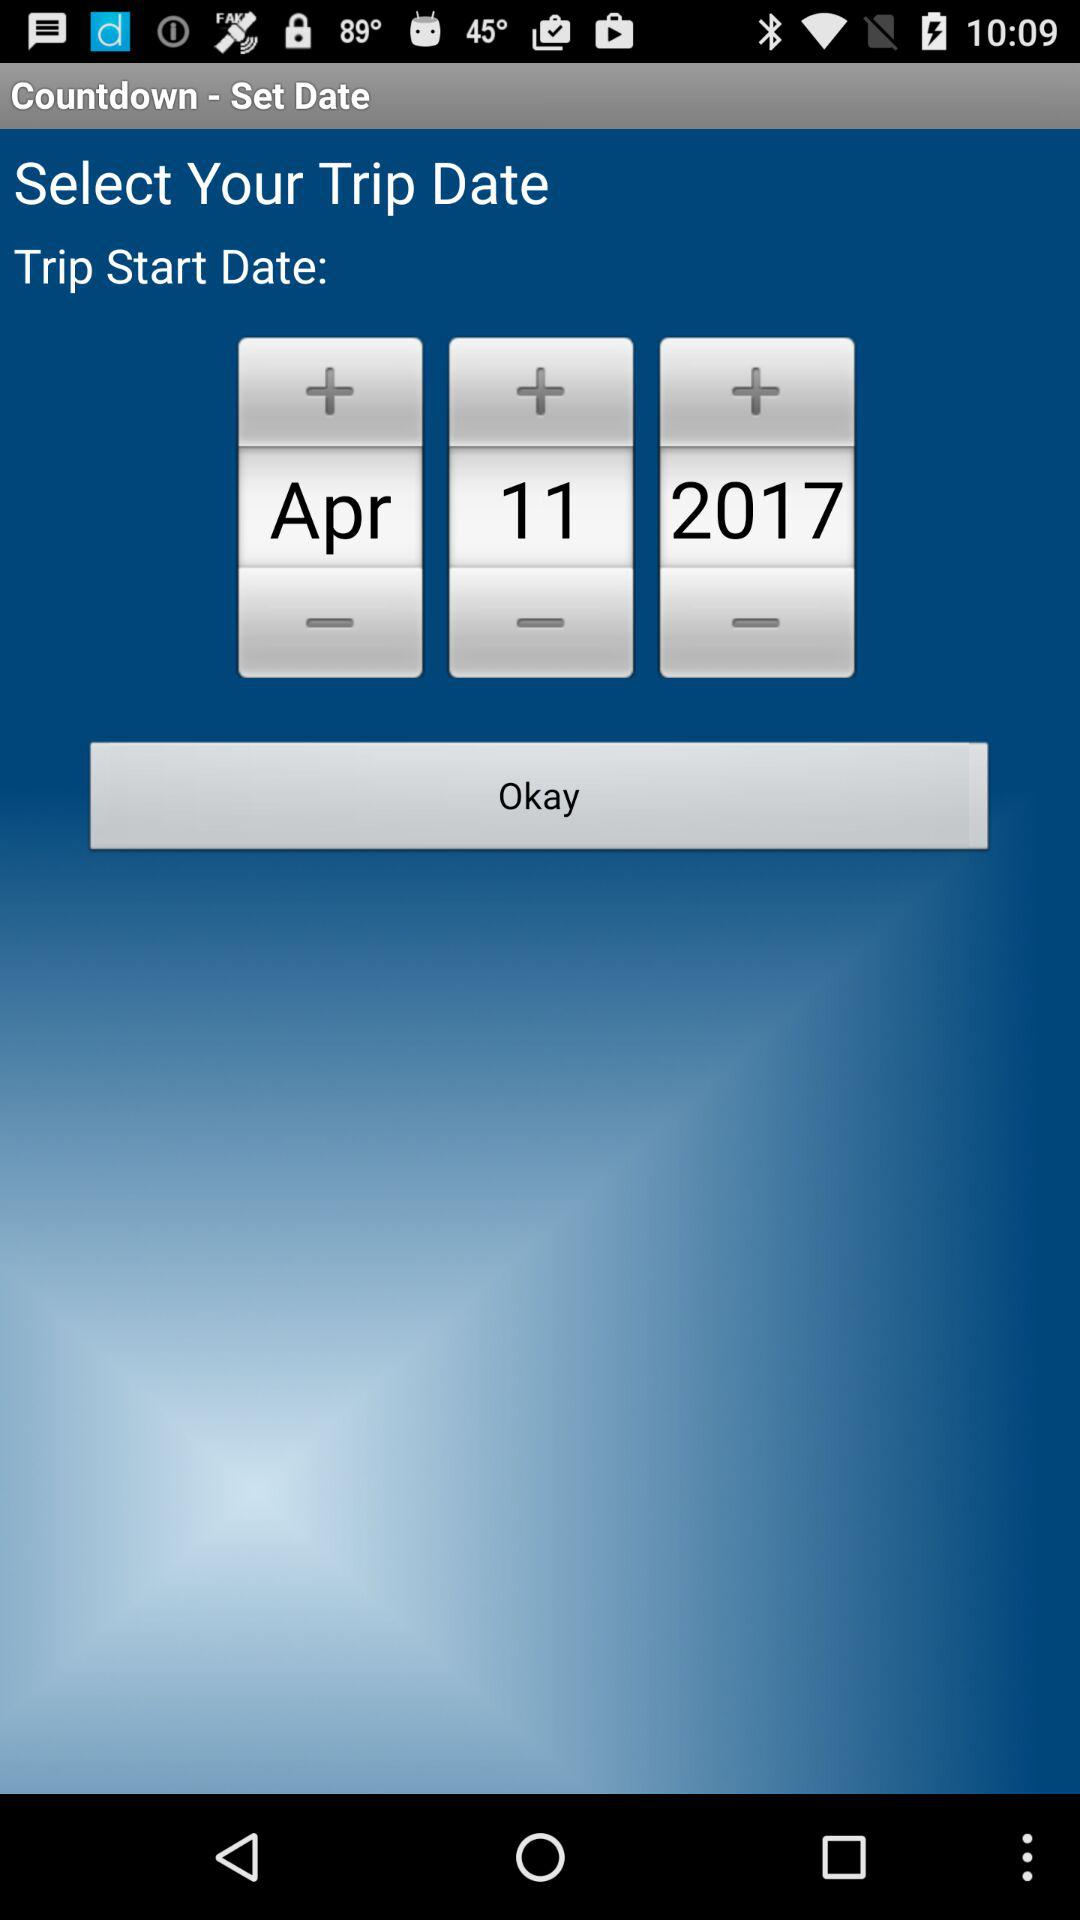What is the selected date for the trip to start? The selected date for the trip to start is April 17, 2017. 